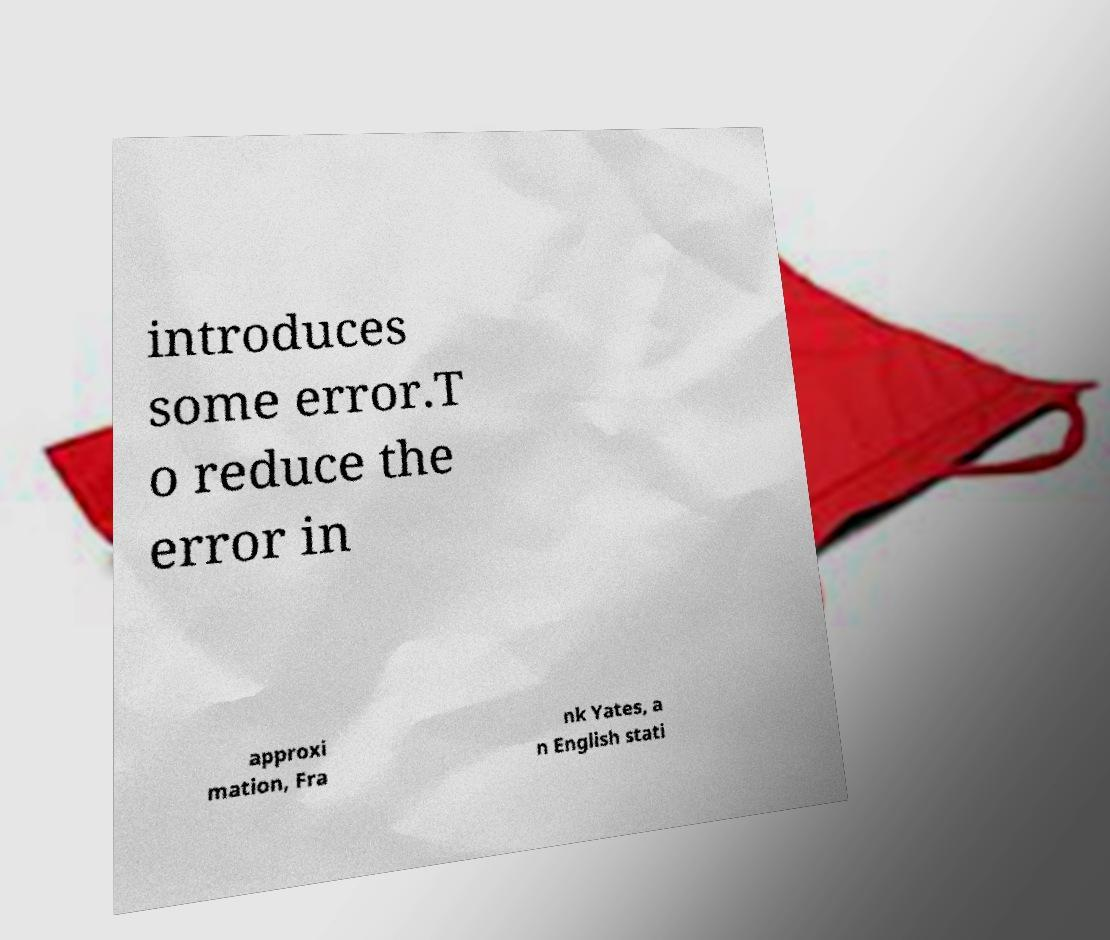I need the written content from this picture converted into text. Can you do that? introduces some error.T o reduce the error in approxi mation, Fra nk Yates, a n English stati 